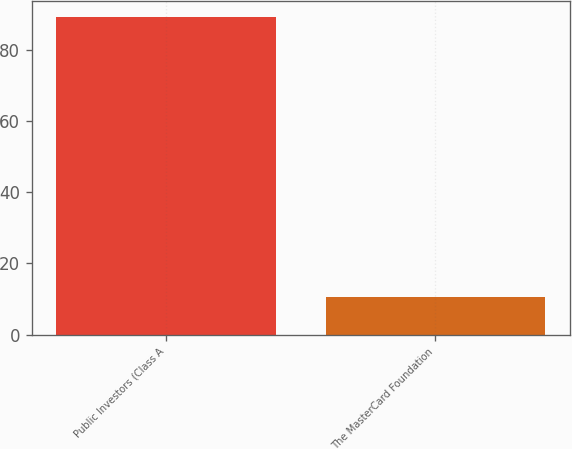Convert chart. <chart><loc_0><loc_0><loc_500><loc_500><bar_chart><fcel>Public Investors (Class A<fcel>The MasterCard Foundation<nl><fcel>89.3<fcel>10.7<nl></chart> 